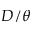Convert formula to latex. <formula><loc_0><loc_0><loc_500><loc_500>D / \theta</formula> 